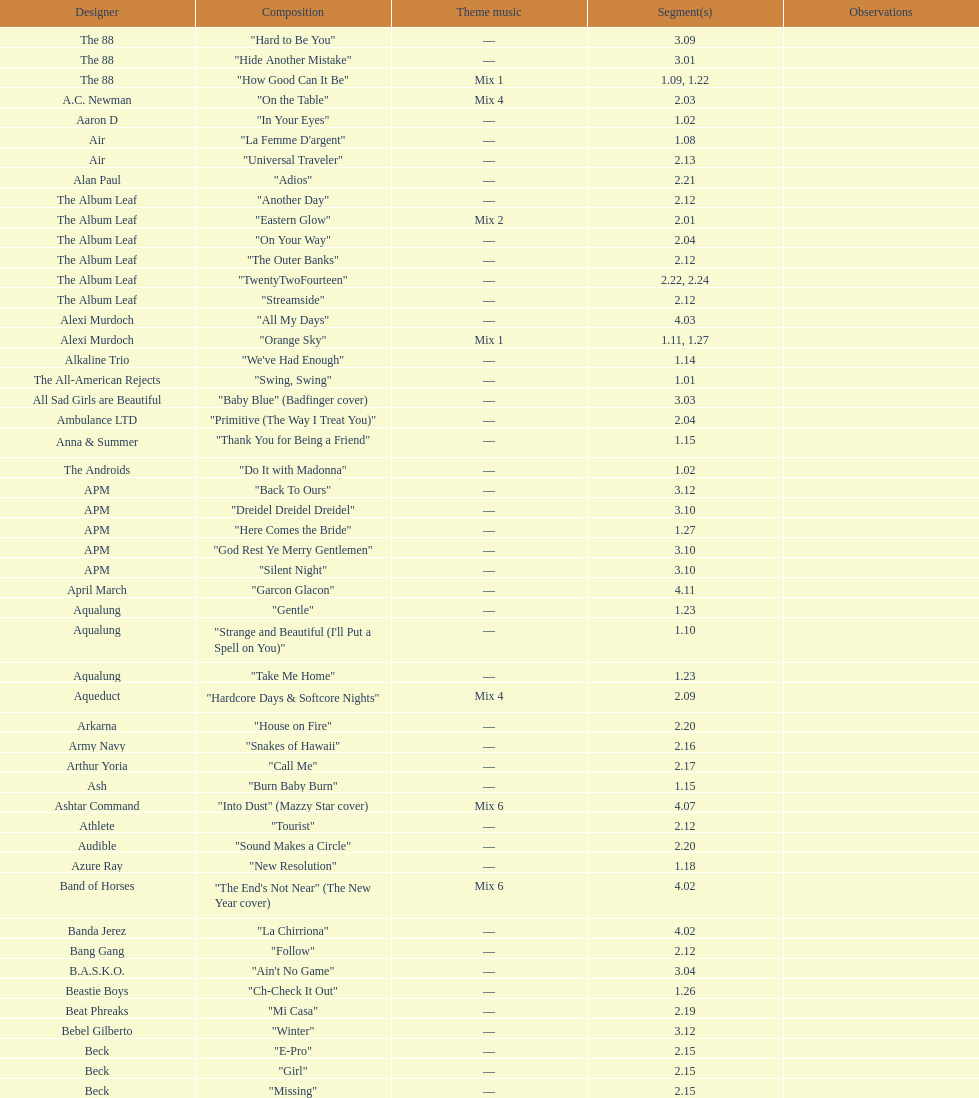"girl" and "el pro" were performed by which artist? Beck. 